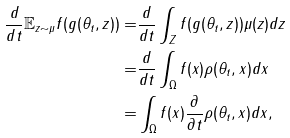<formula> <loc_0><loc_0><loc_500><loc_500>\frac { d } { d t } \mathbb { E } _ { z \sim \mu } f ( g ( \theta _ { t } , z ) ) = & \frac { d } { d t } \int _ { Z } f ( g ( \theta _ { t } , z ) ) \mu ( z ) d z \\ = & \frac { d } { d t } \int _ { \Omega } f ( x ) \rho ( \theta _ { t } , x ) d x \\ = & \int _ { \Omega } f ( x ) \frac { \partial } { \partial t } \rho ( \theta _ { t } , x ) d x ,</formula> 